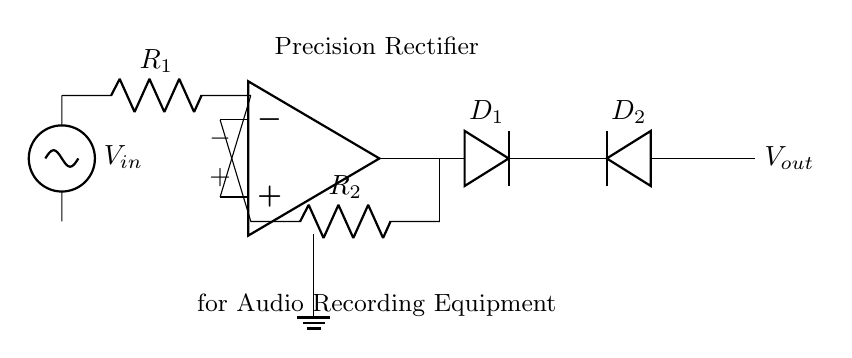What is the function of the diodes in this circuit? The diodes, D1 and D2, serve to allow current to flow in one direction only, effectively creating a rectified output based on the input voltage.
Answer: Rectification What is the role of the operational amplifier in this circuit? The operational amplifier amplifies the input voltage signal, providing a higher output signal while maintaining the accuracy needed for audio applications.
Answer: Amplification What are the resistor values labeled R1 and R2? R1 and R2 are the feedback and input resistors which determine the gain of the operational amplifier circuit, though specific values are not provided in the circuit diagram.
Answer: Not specified How many diodes are present in this precision rectifier circuit? There are two diodes present in the circuit, D1 and D2, which work together to achieve precision rectification.
Answer: Two What type of circuit is this a diagram of? This is a diagram of a precision rectifier circuit, which is specifically designed for processing audio signals accurately.
Answer: Precision rectifier What happens to the output voltage when the input voltage is negative? When the input voltage is negative, the output voltage will be zero due to the behavior of the diodes, which block negative current flow.
Answer: Zero Why is the circuit labeled for audio recording equipment? The precision rectifier is optimized for audio applications, ensuring accurate signal processing which is critical for maintaining sound quality in recordings.
Answer: Sound quality 